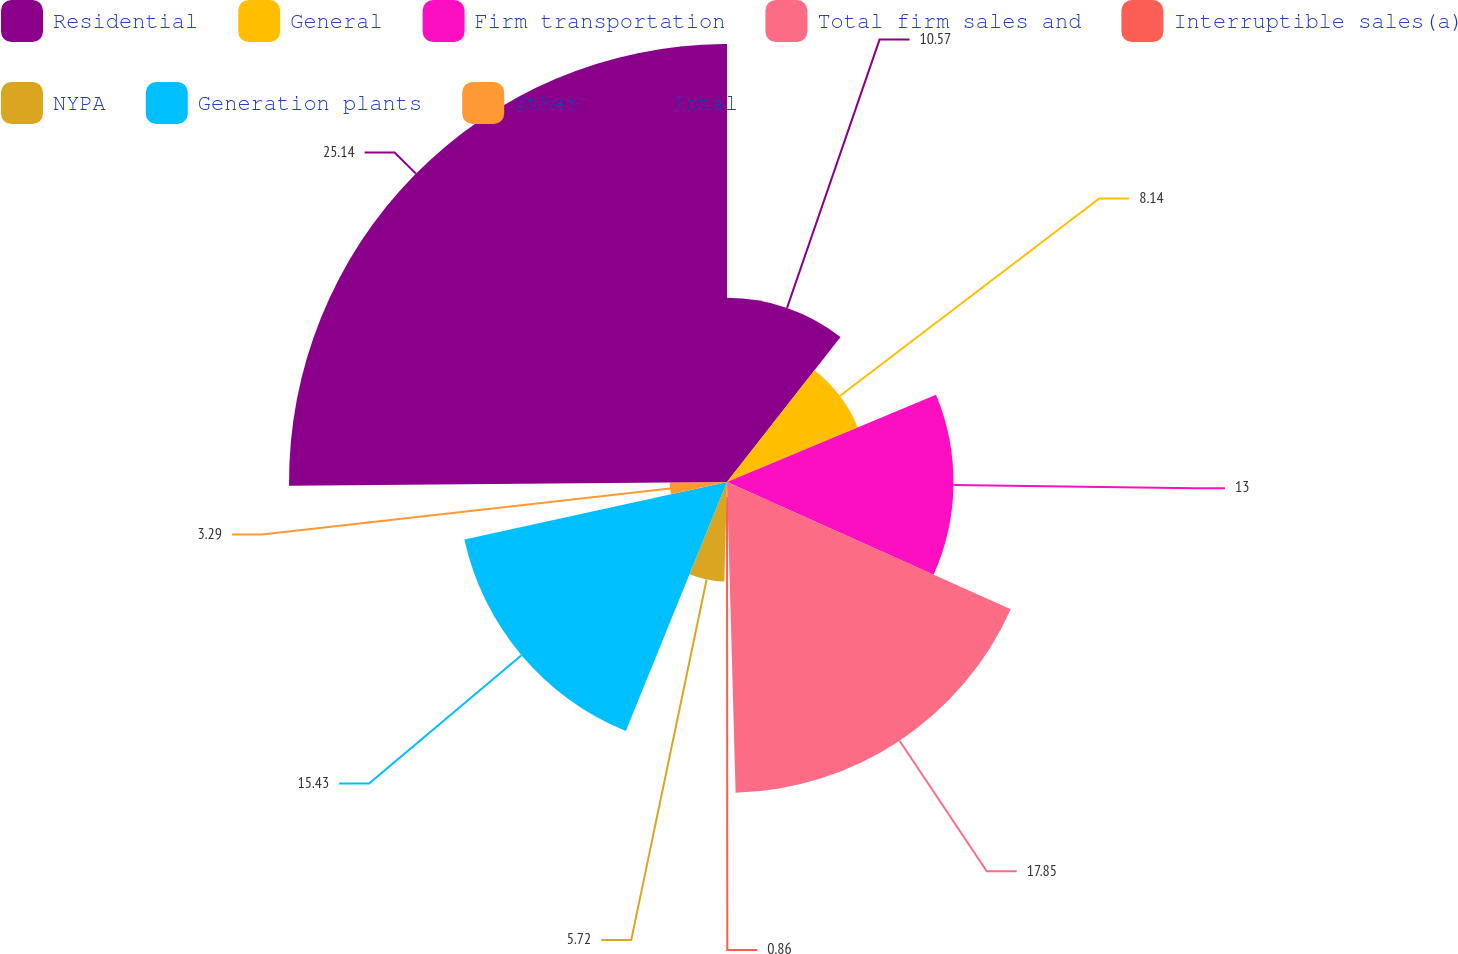<chart> <loc_0><loc_0><loc_500><loc_500><pie_chart><fcel>Residential<fcel>General<fcel>Firm transportation<fcel>Total firm sales and<fcel>Interruptible sales(a)<fcel>NYPA<fcel>Generation plants<fcel>Other<fcel>Total<nl><fcel>10.57%<fcel>8.14%<fcel>13.0%<fcel>17.85%<fcel>0.86%<fcel>5.72%<fcel>15.43%<fcel>3.29%<fcel>25.14%<nl></chart> 